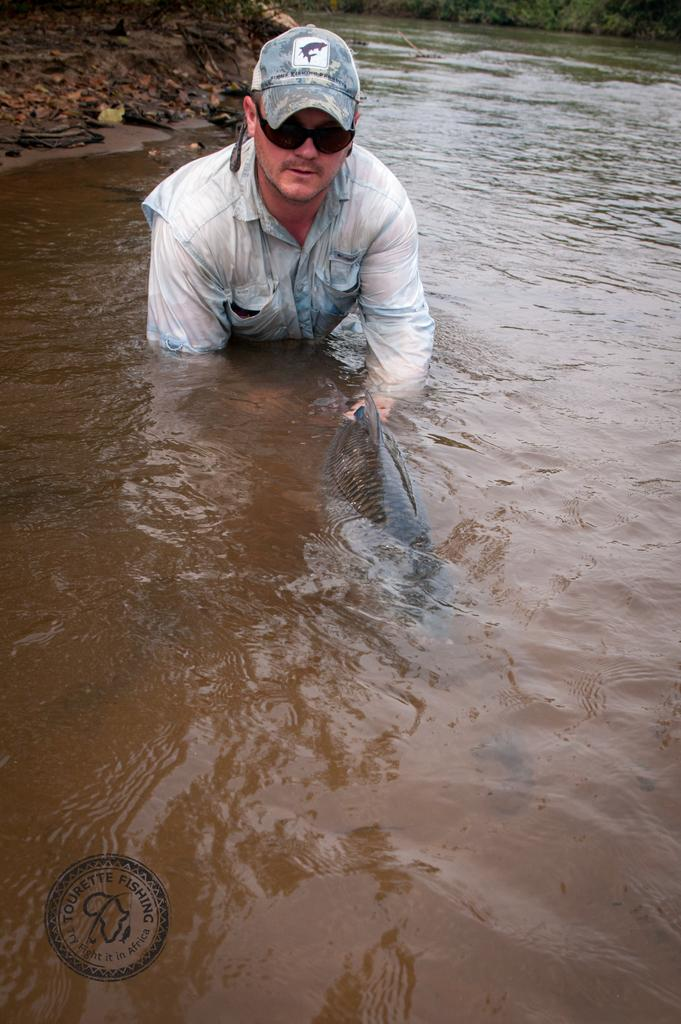Who is present in the image? There is a man in the image. Where is the man located in the image? The man is at the top side of the image. What is the man holding in his hands? The man is holding a fish in his hands. What is the condition of the fish in the image? The fish is in the water. What type of appliance is being used to cook the fish in the image? There is no appliance visible in the image, and the fish is not being cooked; it is in the water. 